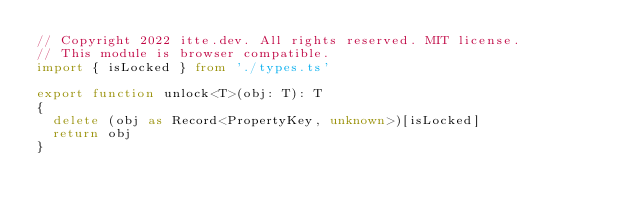<code> <loc_0><loc_0><loc_500><loc_500><_TypeScript_>// Copyright 2022 itte.dev. All rights reserved. MIT license.
// This module is browser compatible.
import { isLocked } from './types.ts'

export function unlock<T>(obj: T): T
{
  delete (obj as Record<PropertyKey, unknown>)[isLocked]
  return obj
}
</code> 